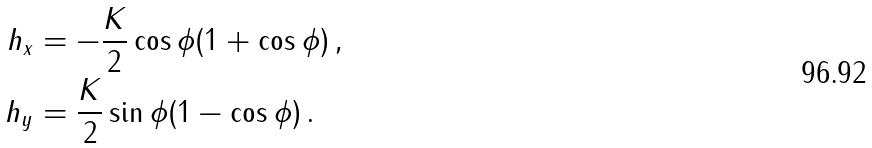Convert formula to latex. <formula><loc_0><loc_0><loc_500><loc_500>h _ { x } & = - \frac { K } { 2 } \cos \phi ( 1 + \cos \phi ) \, , \\ h _ { y } & = \frac { K } { 2 } \sin \phi ( 1 - \cos \phi ) \, .</formula> 